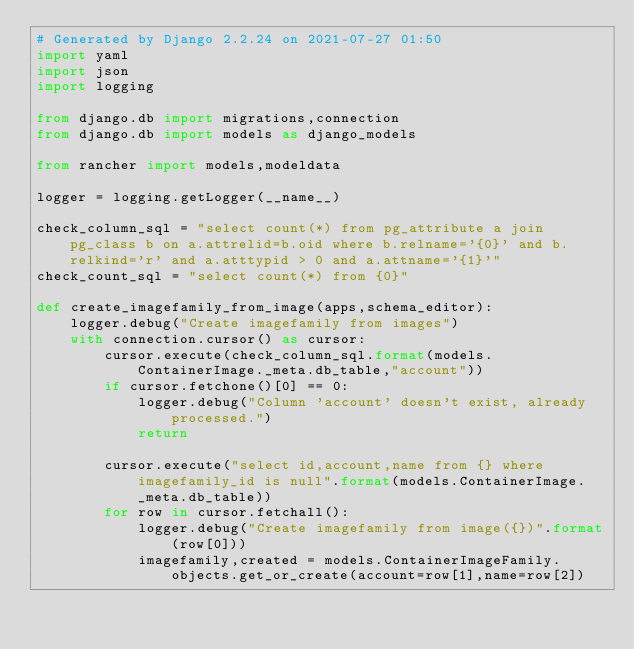Convert code to text. <code><loc_0><loc_0><loc_500><loc_500><_Python_># Generated by Django 2.2.24 on 2021-07-27 01:50
import yaml
import json
import logging

from django.db import migrations,connection
from django.db import models as django_models

from rancher import models,modeldata

logger = logging.getLogger(__name__)

check_column_sql = "select count(*) from pg_attribute a join pg_class b on a.attrelid=b.oid where b.relname='{0}' and b.relkind='r' and a.atttypid > 0 and a.attname='{1}'"
check_count_sql = "select count(*) from {0}"

def create_imagefamily_from_image(apps,schema_editor):
    logger.debug("Create imagefamily from images")
    with connection.cursor() as cursor:
        cursor.execute(check_column_sql.format(models.ContainerImage._meta.db_table,"account"))
        if cursor.fetchone()[0] == 0:
            logger.debug("Column 'account' doesn't exist, already processed.")
            return

        cursor.execute("select id,account,name from {} where imagefamily_id is null".format(models.ContainerImage._meta.db_table))
        for row in cursor.fetchall():
            logger.debug("Create imagefamily from image({})".format(row[0]))
            imagefamily,created = models.ContainerImageFamily.objects.get_or_create(account=row[1],name=row[2])</code> 